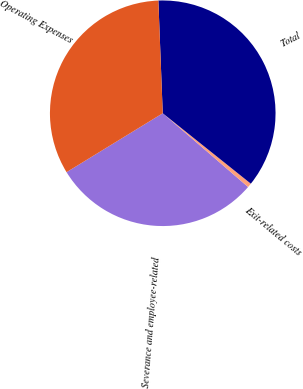Convert chart to OTSL. <chart><loc_0><loc_0><loc_500><loc_500><pie_chart><fcel>Severance and employee-related<fcel>Exit-related costs<fcel>Total<fcel>Operating Expenses<nl><fcel>29.91%<fcel>0.61%<fcel>36.35%<fcel>33.13%<nl></chart> 